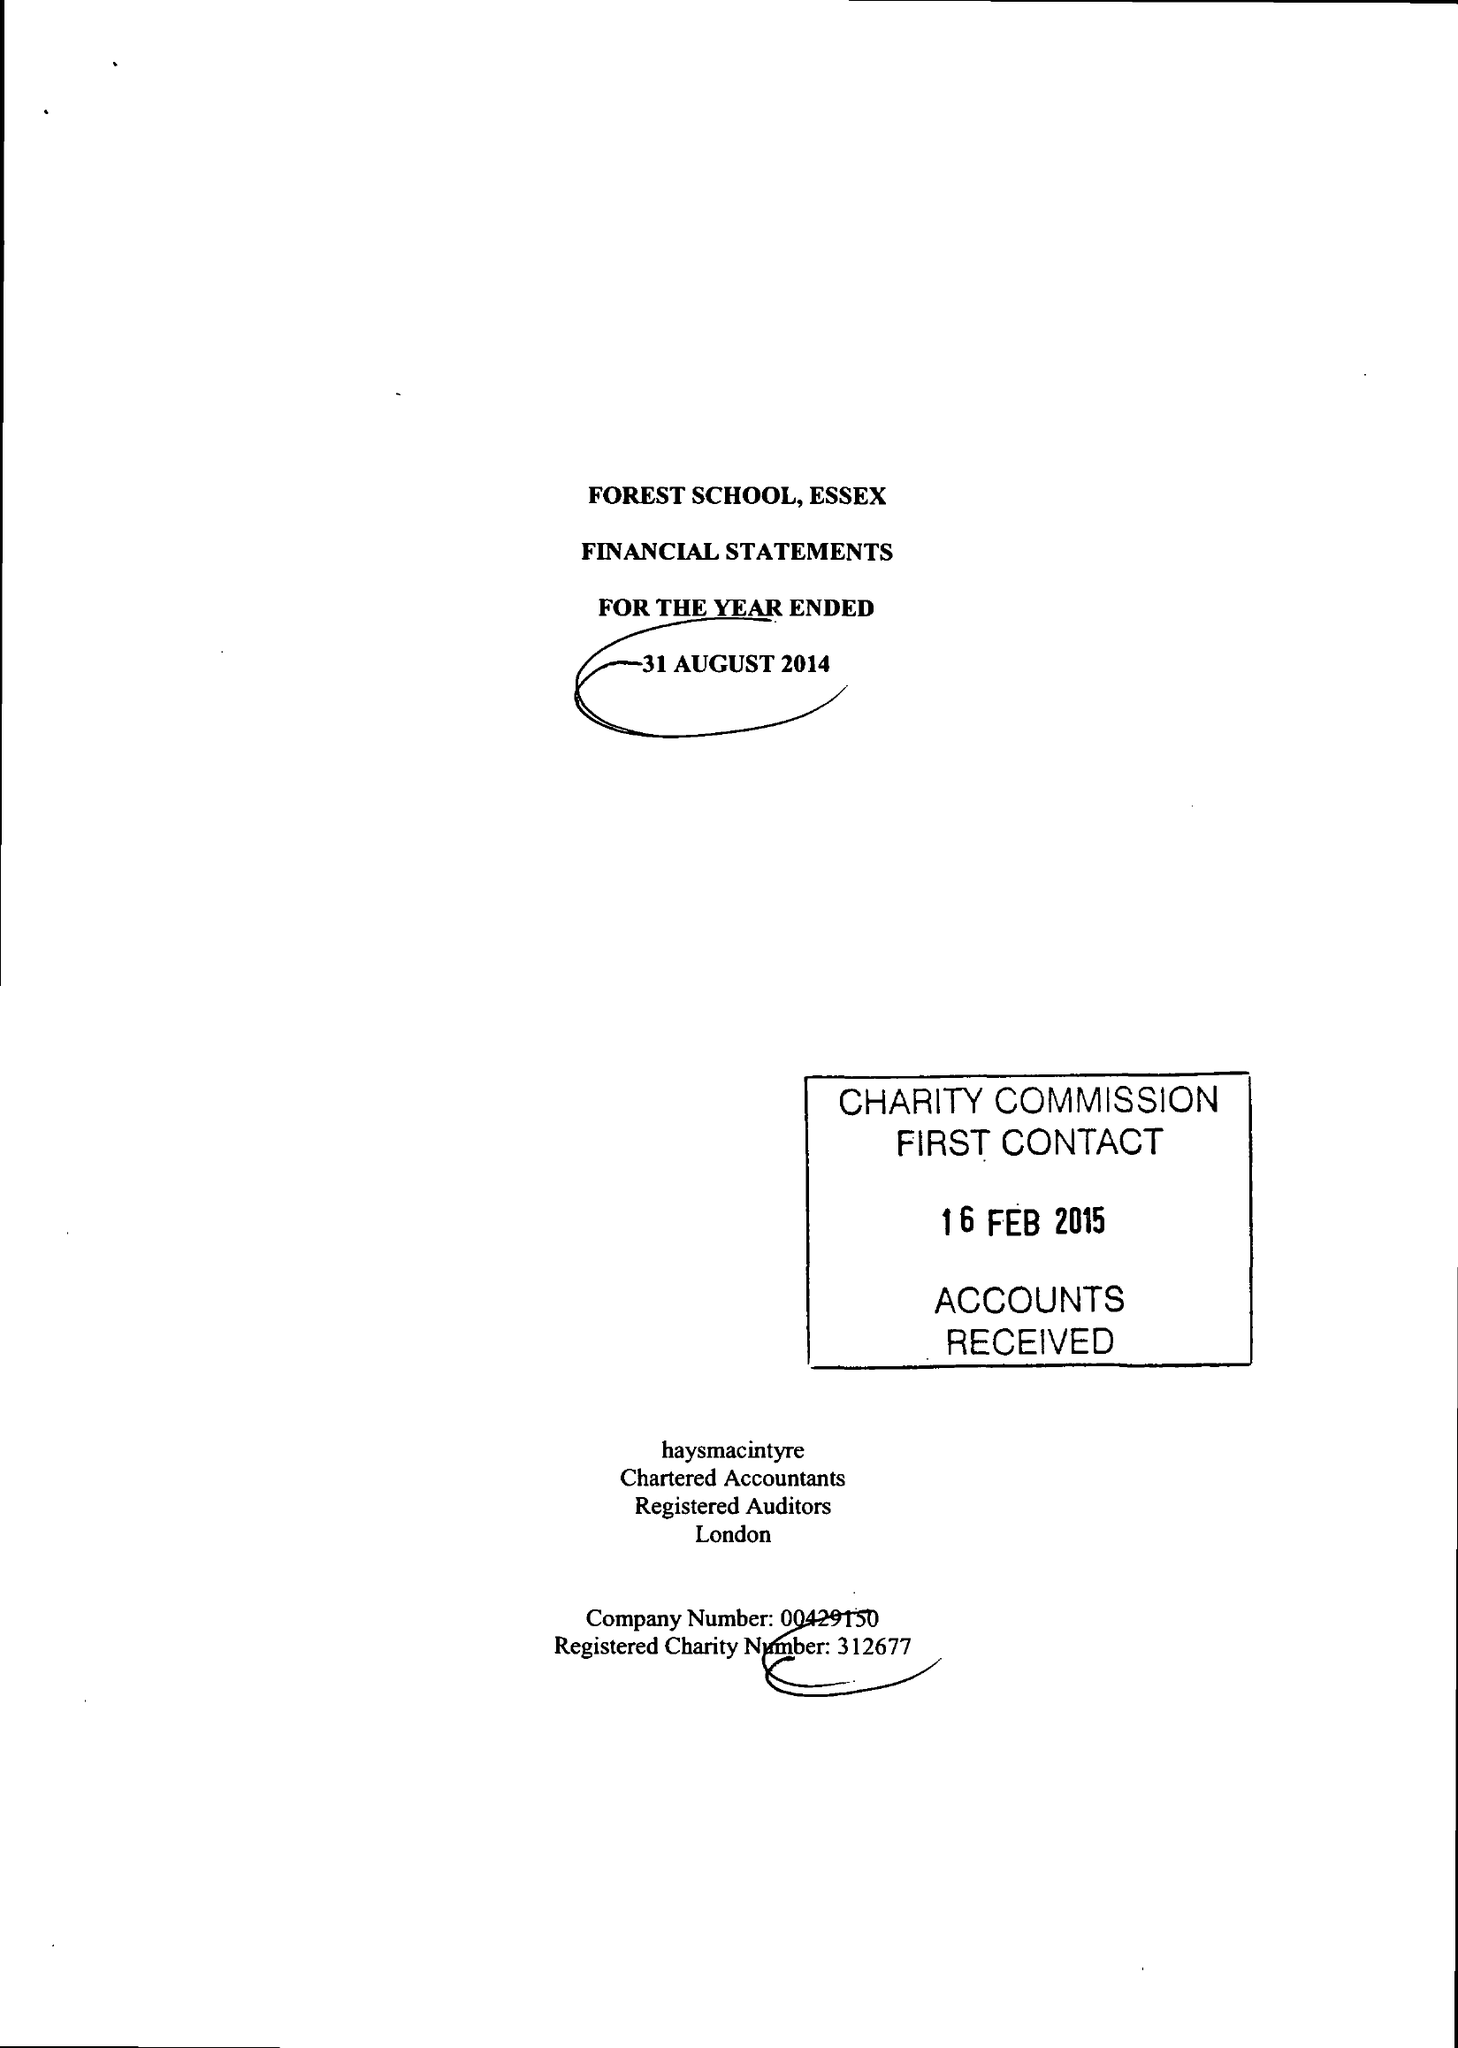What is the value for the income_annually_in_british_pounds?
Answer the question using a single word or phrase. 18293774.00 